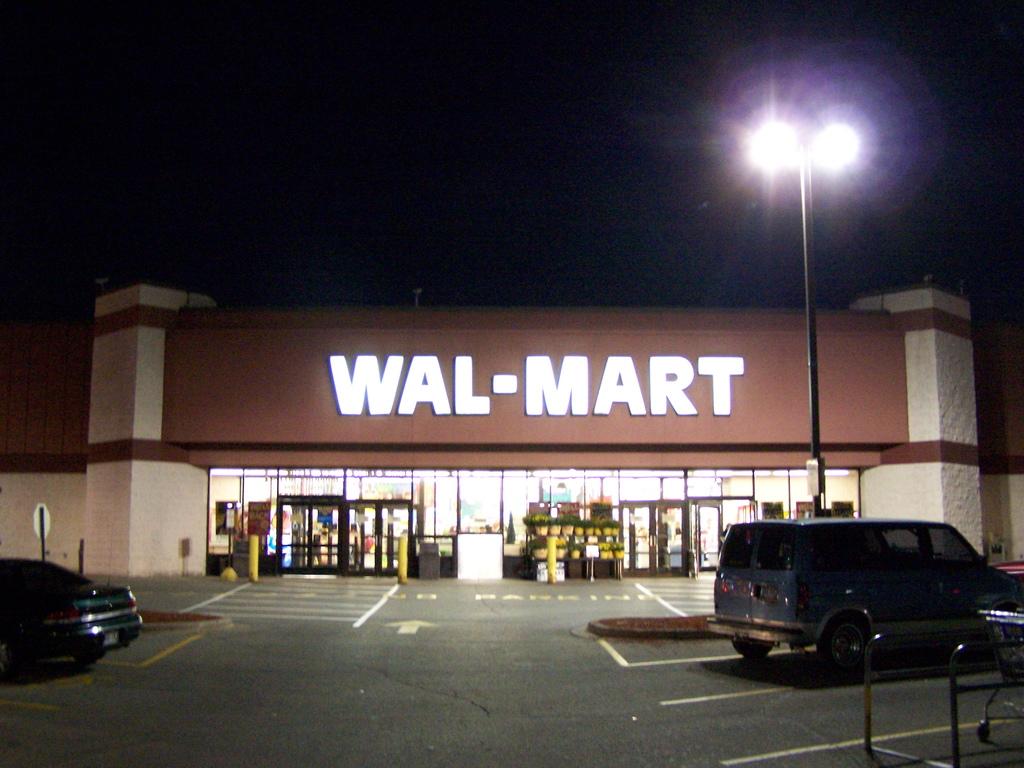Which company is this the entrance of?
Offer a terse response. Wal-mart. What does it say on the road in front of the entrance?
Offer a very short reply. No parking. 